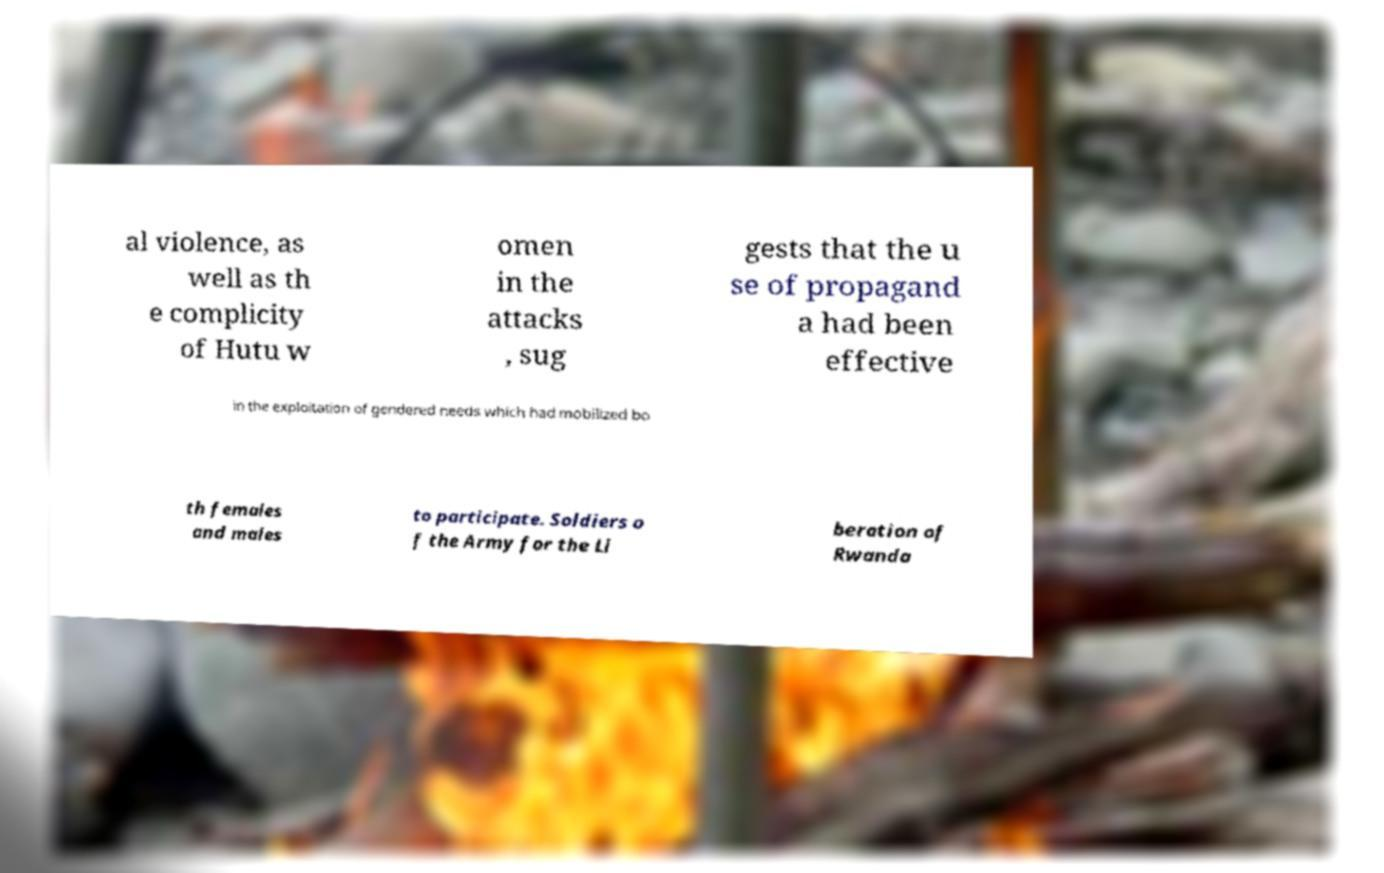Could you extract and type out the text from this image? al violence, as well as th e complicity of Hutu w omen in the attacks , sug gests that the u se of propagand a had been effective in the exploitation of gendered needs which had mobilized bo th females and males to participate. Soldiers o f the Army for the Li beration of Rwanda 